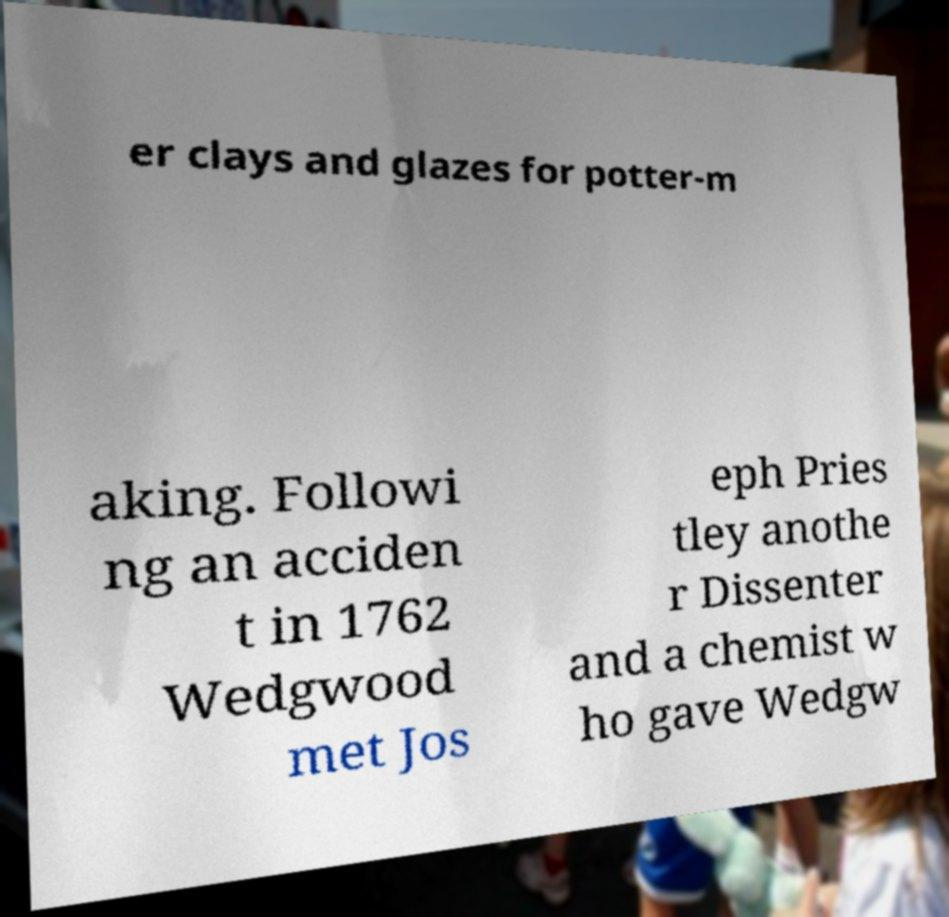Can you read and provide the text displayed in the image?This photo seems to have some interesting text. Can you extract and type it out for me? er clays and glazes for potter-m aking. Followi ng an acciden t in 1762 Wedgwood met Jos eph Pries tley anothe r Dissenter and a chemist w ho gave Wedgw 